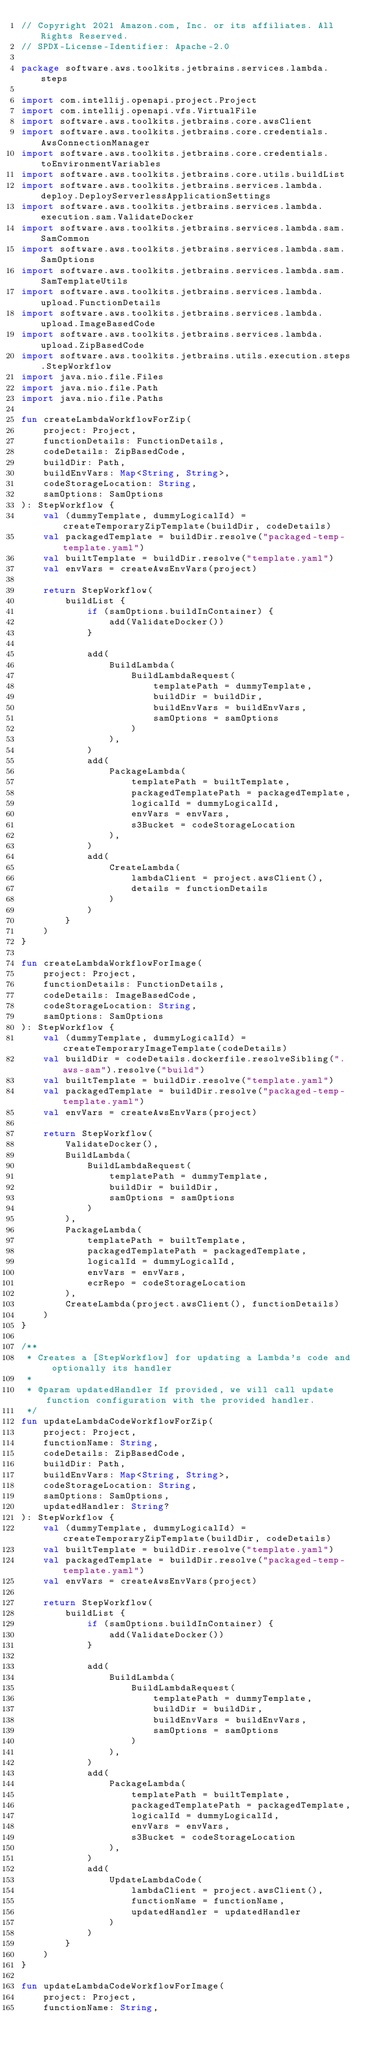<code> <loc_0><loc_0><loc_500><loc_500><_Kotlin_>// Copyright 2021 Amazon.com, Inc. or its affiliates. All Rights Reserved.
// SPDX-License-Identifier: Apache-2.0

package software.aws.toolkits.jetbrains.services.lambda.steps

import com.intellij.openapi.project.Project
import com.intellij.openapi.vfs.VirtualFile
import software.aws.toolkits.jetbrains.core.awsClient
import software.aws.toolkits.jetbrains.core.credentials.AwsConnectionManager
import software.aws.toolkits.jetbrains.core.credentials.toEnvironmentVariables
import software.aws.toolkits.jetbrains.core.utils.buildList
import software.aws.toolkits.jetbrains.services.lambda.deploy.DeployServerlessApplicationSettings
import software.aws.toolkits.jetbrains.services.lambda.execution.sam.ValidateDocker
import software.aws.toolkits.jetbrains.services.lambda.sam.SamCommon
import software.aws.toolkits.jetbrains.services.lambda.sam.SamOptions
import software.aws.toolkits.jetbrains.services.lambda.sam.SamTemplateUtils
import software.aws.toolkits.jetbrains.services.lambda.upload.FunctionDetails
import software.aws.toolkits.jetbrains.services.lambda.upload.ImageBasedCode
import software.aws.toolkits.jetbrains.services.lambda.upload.ZipBasedCode
import software.aws.toolkits.jetbrains.utils.execution.steps.StepWorkflow
import java.nio.file.Files
import java.nio.file.Path
import java.nio.file.Paths

fun createLambdaWorkflowForZip(
    project: Project,
    functionDetails: FunctionDetails,
    codeDetails: ZipBasedCode,
    buildDir: Path,
    buildEnvVars: Map<String, String>,
    codeStorageLocation: String,
    samOptions: SamOptions
): StepWorkflow {
    val (dummyTemplate, dummyLogicalId) = createTemporaryZipTemplate(buildDir, codeDetails)
    val packagedTemplate = buildDir.resolve("packaged-temp-template.yaml")
    val builtTemplate = buildDir.resolve("template.yaml")
    val envVars = createAwsEnvVars(project)

    return StepWorkflow(
        buildList {
            if (samOptions.buildInContainer) {
                add(ValidateDocker())
            }

            add(
                BuildLambda(
                    BuildLambdaRequest(
                        templatePath = dummyTemplate,
                        buildDir = buildDir,
                        buildEnvVars = buildEnvVars,
                        samOptions = samOptions
                    )
                ),
            )
            add(
                PackageLambda(
                    templatePath = builtTemplate,
                    packagedTemplatePath = packagedTemplate,
                    logicalId = dummyLogicalId,
                    envVars = envVars,
                    s3Bucket = codeStorageLocation
                ),
            )
            add(
                CreateLambda(
                    lambdaClient = project.awsClient(),
                    details = functionDetails
                )
            )
        }
    )
}

fun createLambdaWorkflowForImage(
    project: Project,
    functionDetails: FunctionDetails,
    codeDetails: ImageBasedCode,
    codeStorageLocation: String,
    samOptions: SamOptions
): StepWorkflow {
    val (dummyTemplate, dummyLogicalId) = createTemporaryImageTemplate(codeDetails)
    val buildDir = codeDetails.dockerfile.resolveSibling(".aws-sam").resolve("build")
    val builtTemplate = buildDir.resolve("template.yaml")
    val packagedTemplate = buildDir.resolve("packaged-temp-template.yaml")
    val envVars = createAwsEnvVars(project)

    return StepWorkflow(
        ValidateDocker(),
        BuildLambda(
            BuildLambdaRequest(
                templatePath = dummyTemplate,
                buildDir = buildDir,
                samOptions = samOptions
            )
        ),
        PackageLambda(
            templatePath = builtTemplate,
            packagedTemplatePath = packagedTemplate,
            logicalId = dummyLogicalId,
            envVars = envVars,
            ecrRepo = codeStorageLocation
        ),
        CreateLambda(project.awsClient(), functionDetails)
    )
}

/**
 * Creates a [StepWorkflow] for updating a Lambda's code and optionally its handler
 *
 * @param updatedHandler If provided, we will call update function configuration with the provided handler.
 */
fun updateLambdaCodeWorkflowForZip(
    project: Project,
    functionName: String,
    codeDetails: ZipBasedCode,
    buildDir: Path,
    buildEnvVars: Map<String, String>,
    codeStorageLocation: String,
    samOptions: SamOptions,
    updatedHandler: String?
): StepWorkflow {
    val (dummyTemplate, dummyLogicalId) = createTemporaryZipTemplate(buildDir, codeDetails)
    val builtTemplate = buildDir.resolve("template.yaml")
    val packagedTemplate = buildDir.resolve("packaged-temp-template.yaml")
    val envVars = createAwsEnvVars(project)

    return StepWorkflow(
        buildList {
            if (samOptions.buildInContainer) {
                add(ValidateDocker())
            }

            add(
                BuildLambda(
                    BuildLambdaRequest(
                        templatePath = dummyTemplate,
                        buildDir = buildDir,
                        buildEnvVars = buildEnvVars,
                        samOptions = samOptions
                    )
                ),
            )
            add(
                PackageLambda(
                    templatePath = builtTemplate,
                    packagedTemplatePath = packagedTemplate,
                    logicalId = dummyLogicalId,
                    envVars = envVars,
                    s3Bucket = codeStorageLocation
                ),
            )
            add(
                UpdateLambdaCode(
                    lambdaClient = project.awsClient(),
                    functionName = functionName,
                    updatedHandler = updatedHandler
                )
            )
        }
    )
}

fun updateLambdaCodeWorkflowForImage(
    project: Project,
    functionName: String,</code> 